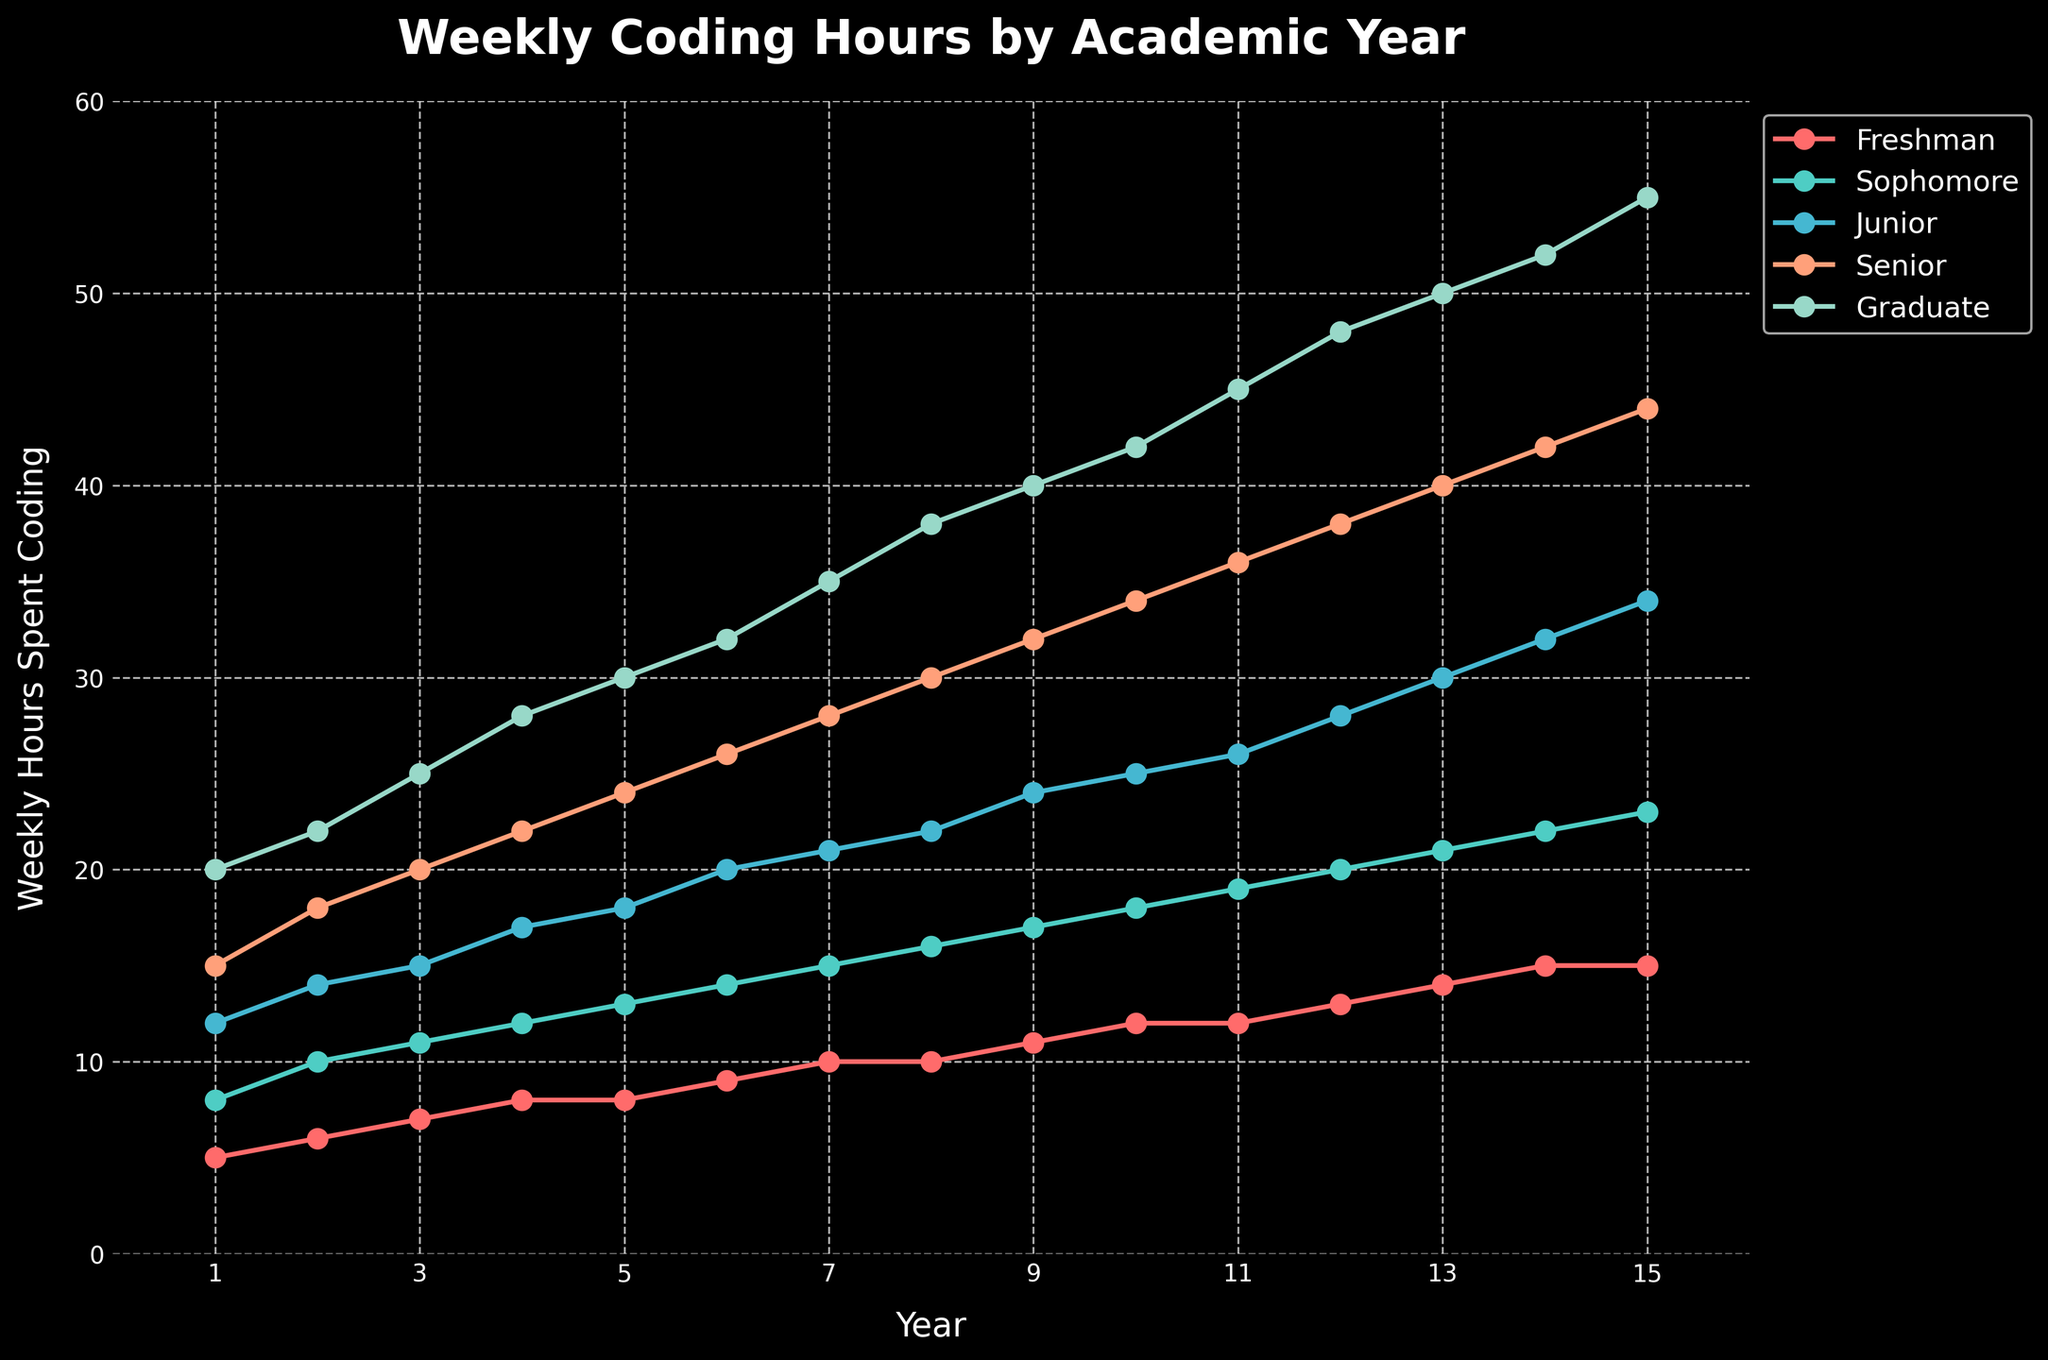What's the average weekly coding hours for Juniors over the 15 years? The weekly coding hours for Juniors over the 15 years are 12, 14, 15, 17, 18, 20, 21, 22, 24, 25, 26, 28, 30, 32, and 34. Sum these values to get 338. Then, divide by 15 to find the average: 338 / 15 ≈ 22.53
Answer: 22.53 Which academic year had the largest increase in coding hours from Freshman to Graduate in the first 5 years? For each year from 1 to 5, subtract the Freshman hours from the Graduate hours: Year 1: 20 - 5 = 15, Year 2: 22 - 6 = 16, Year 3: 25 - 7 = 18, Year 4: 28 - 8 = 20, Year 5: 30 - 8 = 22. Compare these results: the 5th year shows the largest increase of 22 hours.
Answer: 5th year Which group shows the steepest increase in weekly coding hours over the 15 years? By inspecting the slopes of each line in the plot, the Graduate group clearly shows the steepest increase, rising from 20 to 55 hours over 15 years.
Answer: Graduate What is the difference in weekly coding hours between Seniors and Sophomores in the 10th year? In the 10th year, Seniors spend 34 hours coding and Sophomores spend 18 hours. The difference is 34 - 18 = 16 hours.
Answer: 16 hours For which academic year(s) do Freshmen and Sophomores have the same weekly coding hours? The plotted data shows that Freshmen and Sophomores both spend 15 hours coding in the 14th and 15th years.
Answer: 14th and 15th years How many hours more do Seniors spend coding compared to Juniors in the 8th year? In the 8th year, Seniors spend 30 hours coding and Juniors spend 22 hours. The difference is 30 - 22 = 8 hours.
Answer: 8 hours Between which years does the coding hour spent by Juniors exhibit the greatest increase? By examining the year-over-year increases for Juniors: (14 - 12) = 2, (15 - 14) = 1, (17 - 15) = 2, (18 - 17) = 1, (20 - 18) = 2, (21 - 20) = 1, (22 - 21) = 1, (24 - 22) = 2, (25 - 24) = 1, (26 - 25) = 1, (28 - 26) = 2, (30 - 28) = 2, (32 - 30) = 2, (34 - 32) = 2. The increases of 2 happen multiple times, but they are all equal, not a single "greatest" year pair.
Answer: Multiple What is the color of the line representing Sophomores? By inspecting the legend in the plot, the color of the Sophomore line appears as a teal color.
Answer: Teal How many total coding hours did Freshmen spend over the 15 years? The weekly coding hours for Freshmen over the 15 years are 5, 6, 7, 8, 8, 9, 10, 10, 11, 12, 12, 13, 14, 15, and 15. Sum these values to get the total: 5 + 6 + 7 + 8 + 8 + 9 + 10 + 10 + 11 + 12 + 12 + 13 + 14 + 15 + 15 = 155 hours.
Answer: 155 